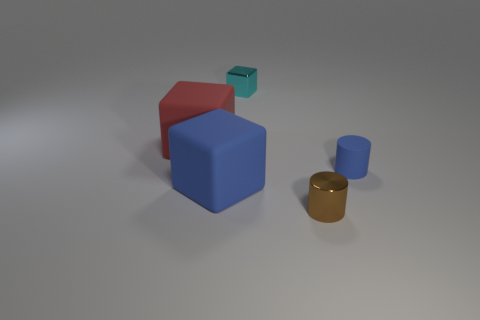What shape is the blue object that is on the left side of the metallic cylinder?
Provide a short and direct response. Cube. What shape is the small blue thing that is made of the same material as the blue cube?
Provide a succinct answer. Cylinder. There is a small blue matte cylinder; how many big blue things are in front of it?
Make the answer very short. 1. Is the number of blue objects to the left of the tiny cyan metal thing the same as the number of tiny brown metallic objects?
Ensure brevity in your answer.  Yes. Are the red thing and the tiny cube made of the same material?
Keep it short and to the point. No. There is a cube that is behind the blue matte cube and in front of the tiny cyan metal thing; what size is it?
Provide a succinct answer. Large. How many other rubber blocks are the same size as the blue block?
Provide a short and direct response. 1. There is a matte cube behind the blue matte thing to the right of the small cyan metallic block; what size is it?
Make the answer very short. Large. Does the big thing that is in front of the red rubber thing have the same shape as the rubber thing that is on the right side of the tiny metal block?
Keep it short and to the point. No. There is a rubber thing that is both on the left side of the blue rubber cylinder and behind the blue cube; what color is it?
Keep it short and to the point. Red. 